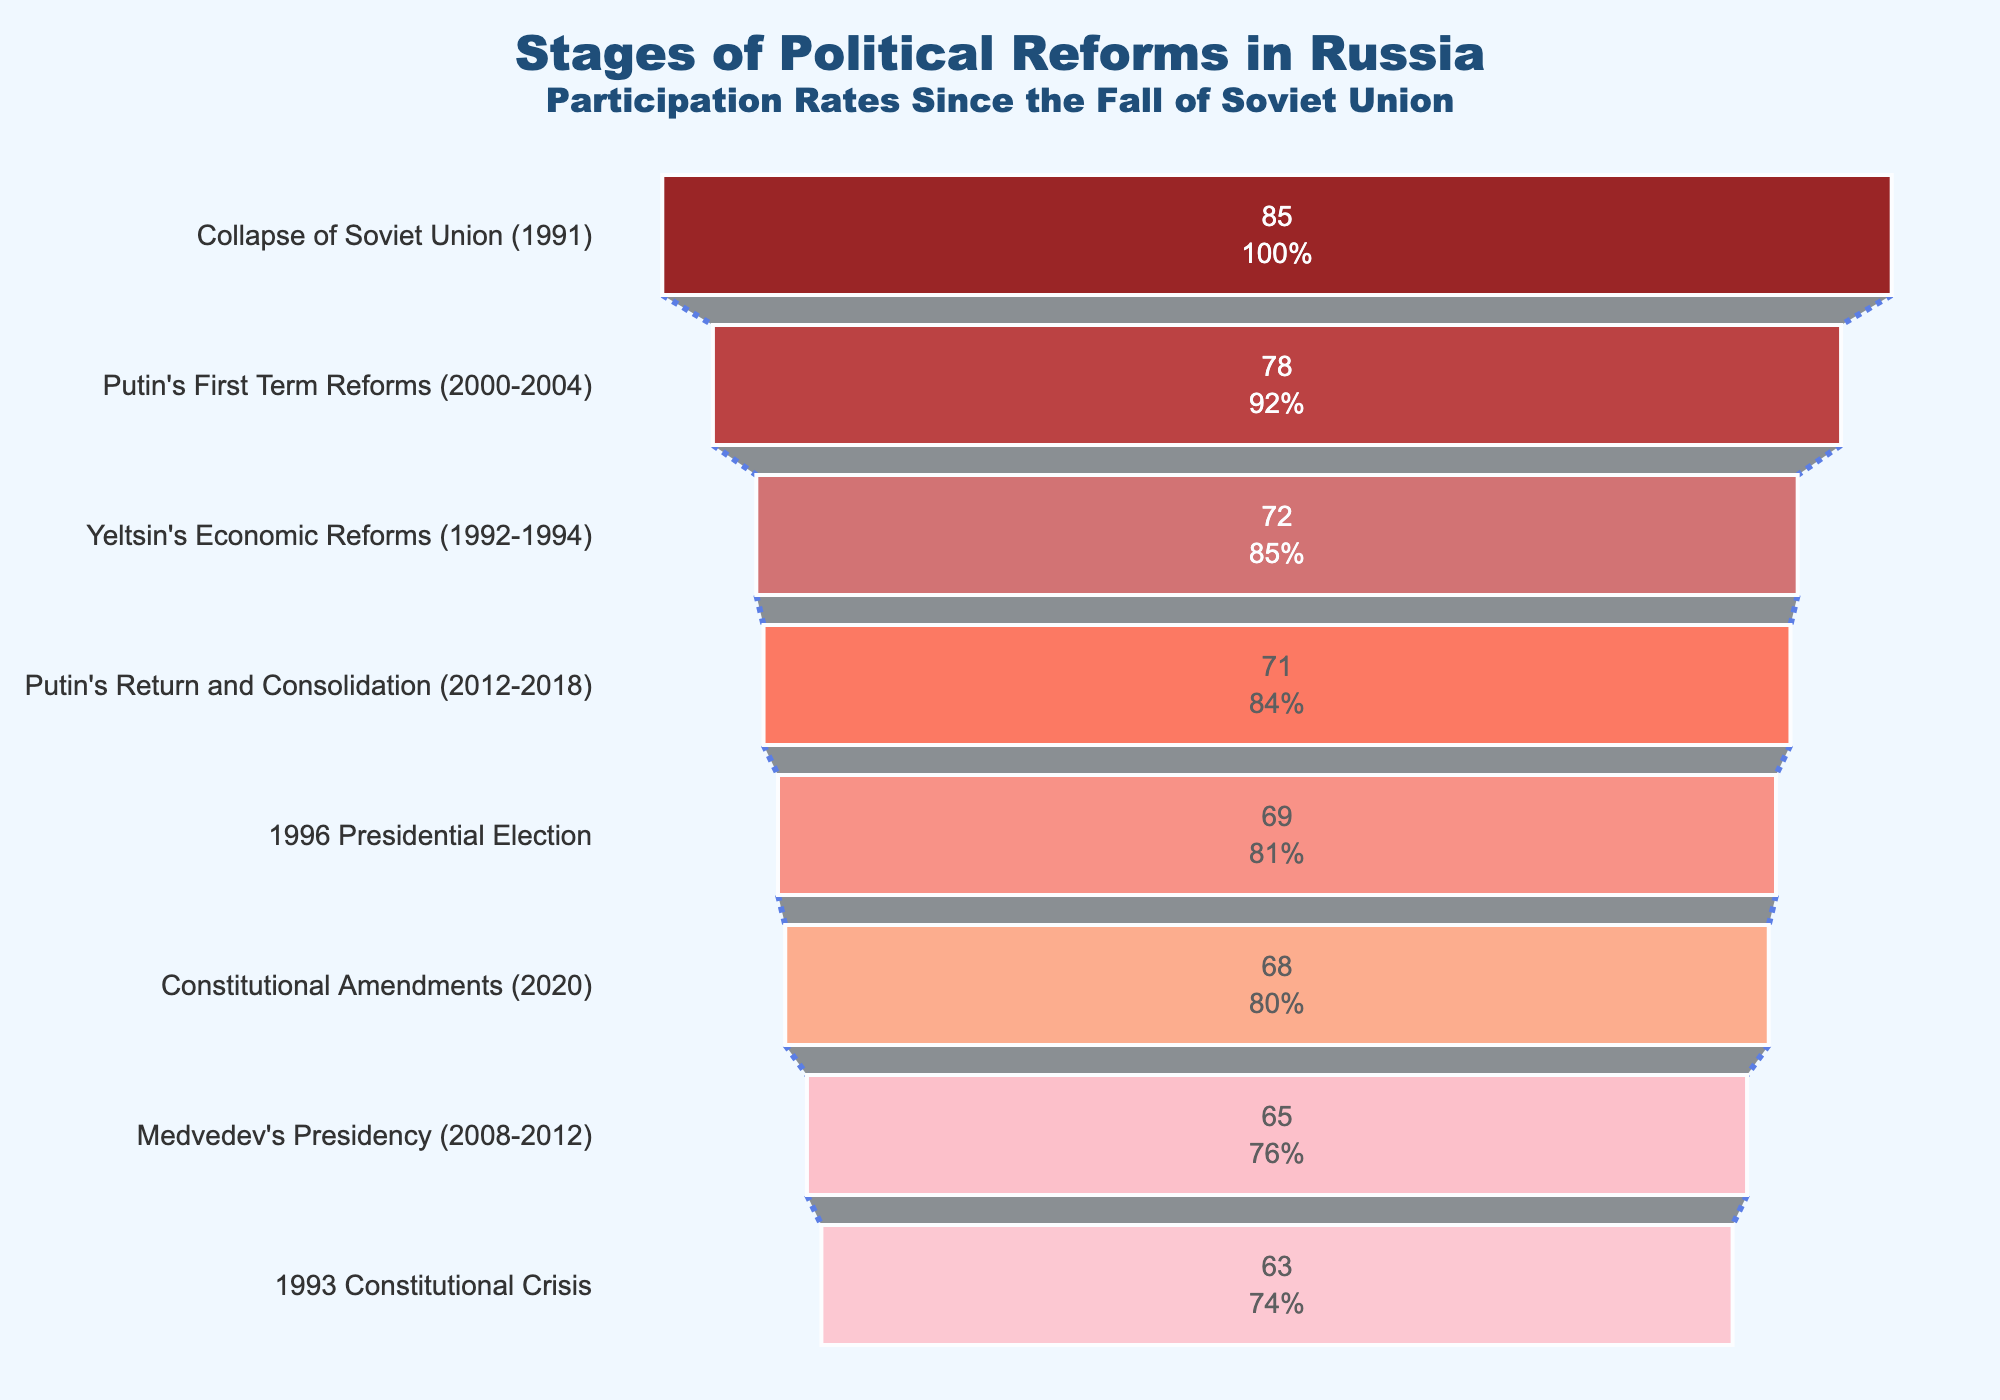What event had the highest participation rate? The highest participation rate is indicated by the largest horizontal section in the funnel, which is "Collapse of Soviet Union (1991)" at 85%.
Answer: Collapse of Soviet Union (1991) What is the participation rate for Putin's First Term Reforms (2000-2004)? Locate "Putin's First Term Reforms (2000-2004)" in the funnel chart and see that it has a participation rate given as 78%.
Answer: 78% Which event had the lowest participation rate? The smallest horizontal section in the funnel corresponds to the lowest participation rate, which is the "1993 Constitutional Crisis" at 63%.
Answer: 1993 Constitutional Crisis What is the difference in participation rates between the 1993 Constitutional Crisis and the Collapse of the Soviet Union? The participation rates for these two stages are 63% and 85%, respectively. The difference is 85% - 63% = 22%.
Answer: 22% Which stages had a participation rate of more than 70%? From the funnel chart, the stages with participation rates above 70% are: "Collapse of Soviet Union (1991)", "Yeltsin's Economic Reforms (1992-1994)", "1996 Presidential Election", "Putin's First Term Reforms (2000-2004)", and "Putin's Return and Consolidation (2012-2018)".
Answer: 5 stages How does the participation rate for Medvedev's Presidency compare to that of Putin's First Term Reforms? The funnel chart shows that Medvedev's Presidency had a participation rate of 65%, while Putin's First Term Reforms had 78%. Hence, Medvedev's Presidency has a lower participation rate than Putin's First Term Reforms.
Answer: Medvedev's Presidency is lower How many stages had a participation rate between 65% and 70%? The stages falling within the 65%-70% range from the funnel chart are "1993 Constitutional Crisis", "1996 Presidential Election", "Medvedev's Presidency (2008-2012)", and "Constitutional Amendments (2020)". There are four such stages.
Answer: 4 stages What was the participation rate for the 2020 Constitutional Amendments? Find the "Constitutional Amendments (2020)" section in the funnel chart, which shows a participation rate of 68%.
Answer: 68% Which stage had a higher participation rate: Yeltsin's Economic Reforms or the 1996 Presidential Election? Yeltsin's Economic Reforms had a participation rate of 72%, while the 1996 Presidential Election had a rate of 69%. Hence, Yeltsin's Economic Reforms had a higher participation rate.
Answer: Yeltsin's Economic Reforms What percentage of the stages had a participation rate over 65%? There are 8 stages in total, and 7 of them have participation rates over 65%. The percentage is calculated as (7/8)*100 = 87.5%.
Answer: 87.5% 